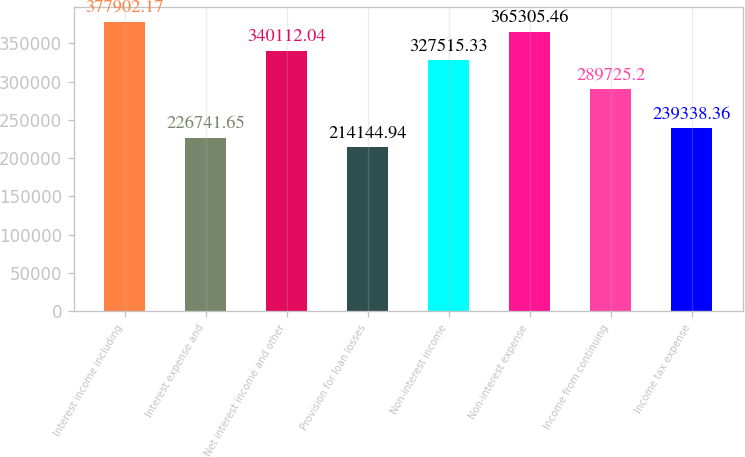Convert chart. <chart><loc_0><loc_0><loc_500><loc_500><bar_chart><fcel>Interest income including<fcel>Interest expense and<fcel>Net interest income and other<fcel>Provision for loan losses<fcel>Non-interest income<fcel>Non-interest expense<fcel>Income from continuing<fcel>Income tax expense<nl><fcel>377902<fcel>226742<fcel>340112<fcel>214145<fcel>327515<fcel>365305<fcel>289725<fcel>239338<nl></chart> 